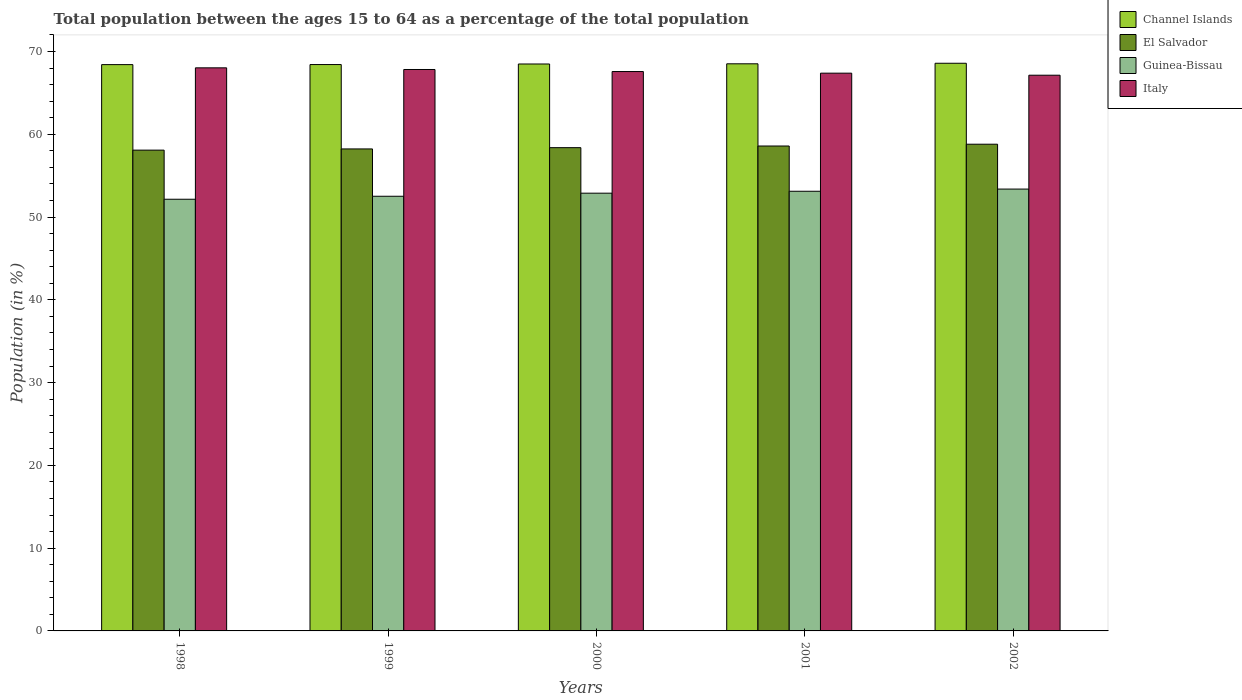How many groups of bars are there?
Give a very brief answer. 5. How many bars are there on the 1st tick from the left?
Your response must be concise. 4. How many bars are there on the 1st tick from the right?
Ensure brevity in your answer.  4. What is the label of the 4th group of bars from the left?
Ensure brevity in your answer.  2001. In how many cases, is the number of bars for a given year not equal to the number of legend labels?
Make the answer very short. 0. What is the percentage of the population ages 15 to 64 in Channel Islands in 1999?
Ensure brevity in your answer.  68.43. Across all years, what is the maximum percentage of the population ages 15 to 64 in Italy?
Provide a short and direct response. 68.03. Across all years, what is the minimum percentage of the population ages 15 to 64 in Italy?
Your answer should be very brief. 67.14. In which year was the percentage of the population ages 15 to 64 in Guinea-Bissau maximum?
Offer a terse response. 2002. What is the total percentage of the population ages 15 to 64 in Guinea-Bissau in the graph?
Provide a short and direct response. 264.06. What is the difference between the percentage of the population ages 15 to 64 in Italy in 1998 and that in 2000?
Keep it short and to the point. 0.45. What is the difference between the percentage of the population ages 15 to 64 in El Salvador in 2000 and the percentage of the population ages 15 to 64 in Guinea-Bissau in 1999?
Your response must be concise. 5.87. What is the average percentage of the population ages 15 to 64 in El Salvador per year?
Your answer should be compact. 58.42. In the year 2000, what is the difference between the percentage of the population ages 15 to 64 in Channel Islands and percentage of the population ages 15 to 64 in Guinea-Bissau?
Your answer should be very brief. 15.61. What is the ratio of the percentage of the population ages 15 to 64 in Italy in 2000 to that in 2002?
Your response must be concise. 1.01. Is the percentage of the population ages 15 to 64 in El Salvador in 2001 less than that in 2002?
Ensure brevity in your answer.  Yes. Is the difference between the percentage of the population ages 15 to 64 in Channel Islands in 1999 and 2002 greater than the difference between the percentage of the population ages 15 to 64 in Guinea-Bissau in 1999 and 2002?
Offer a terse response. Yes. What is the difference between the highest and the second highest percentage of the population ages 15 to 64 in Guinea-Bissau?
Your response must be concise. 0.26. What is the difference between the highest and the lowest percentage of the population ages 15 to 64 in El Salvador?
Keep it short and to the point. 0.72. In how many years, is the percentage of the population ages 15 to 64 in Guinea-Bissau greater than the average percentage of the population ages 15 to 64 in Guinea-Bissau taken over all years?
Offer a very short reply. 3. What does the 4th bar from the left in 2001 represents?
Provide a short and direct response. Italy. What does the 2nd bar from the right in 2001 represents?
Your answer should be very brief. Guinea-Bissau. Is it the case that in every year, the sum of the percentage of the population ages 15 to 64 in Italy and percentage of the population ages 15 to 64 in Guinea-Bissau is greater than the percentage of the population ages 15 to 64 in El Salvador?
Offer a terse response. Yes. How many bars are there?
Provide a short and direct response. 20. Are all the bars in the graph horizontal?
Your answer should be very brief. No. How many years are there in the graph?
Offer a very short reply. 5. What is the difference between two consecutive major ticks on the Y-axis?
Ensure brevity in your answer.  10. Does the graph contain any zero values?
Make the answer very short. No. Does the graph contain grids?
Provide a short and direct response. No. Where does the legend appear in the graph?
Provide a succinct answer. Top right. How are the legend labels stacked?
Ensure brevity in your answer.  Vertical. What is the title of the graph?
Make the answer very short. Total population between the ages 15 to 64 as a percentage of the total population. What is the label or title of the Y-axis?
Ensure brevity in your answer.  Population (in %). What is the Population (in %) in Channel Islands in 1998?
Offer a terse response. 68.42. What is the Population (in %) of El Salvador in 1998?
Provide a short and direct response. 58.09. What is the Population (in %) in Guinea-Bissau in 1998?
Your response must be concise. 52.16. What is the Population (in %) of Italy in 1998?
Make the answer very short. 68.03. What is the Population (in %) in Channel Islands in 1999?
Provide a short and direct response. 68.43. What is the Population (in %) in El Salvador in 1999?
Keep it short and to the point. 58.23. What is the Population (in %) in Guinea-Bissau in 1999?
Offer a very short reply. 52.52. What is the Population (in %) of Italy in 1999?
Your answer should be compact. 67.83. What is the Population (in %) in Channel Islands in 2000?
Provide a short and direct response. 68.5. What is the Population (in %) of El Salvador in 2000?
Offer a very short reply. 58.39. What is the Population (in %) in Guinea-Bissau in 2000?
Ensure brevity in your answer.  52.89. What is the Population (in %) in Italy in 2000?
Make the answer very short. 67.58. What is the Population (in %) of Channel Islands in 2001?
Make the answer very short. 68.52. What is the Population (in %) of El Salvador in 2001?
Ensure brevity in your answer.  58.59. What is the Population (in %) in Guinea-Bissau in 2001?
Your answer should be compact. 53.12. What is the Population (in %) in Italy in 2001?
Your response must be concise. 67.39. What is the Population (in %) of Channel Islands in 2002?
Give a very brief answer. 68.58. What is the Population (in %) of El Salvador in 2002?
Your answer should be compact. 58.8. What is the Population (in %) of Guinea-Bissau in 2002?
Ensure brevity in your answer.  53.38. What is the Population (in %) in Italy in 2002?
Your response must be concise. 67.14. Across all years, what is the maximum Population (in %) of Channel Islands?
Provide a short and direct response. 68.58. Across all years, what is the maximum Population (in %) in El Salvador?
Offer a terse response. 58.8. Across all years, what is the maximum Population (in %) of Guinea-Bissau?
Make the answer very short. 53.38. Across all years, what is the maximum Population (in %) in Italy?
Keep it short and to the point. 68.03. Across all years, what is the minimum Population (in %) in Channel Islands?
Your answer should be compact. 68.42. Across all years, what is the minimum Population (in %) of El Salvador?
Provide a short and direct response. 58.09. Across all years, what is the minimum Population (in %) in Guinea-Bissau?
Make the answer very short. 52.16. Across all years, what is the minimum Population (in %) in Italy?
Provide a succinct answer. 67.14. What is the total Population (in %) in Channel Islands in the graph?
Give a very brief answer. 342.45. What is the total Population (in %) of El Salvador in the graph?
Your response must be concise. 292.1. What is the total Population (in %) in Guinea-Bissau in the graph?
Make the answer very short. 264.06. What is the total Population (in %) of Italy in the graph?
Provide a short and direct response. 337.98. What is the difference between the Population (in %) in Channel Islands in 1998 and that in 1999?
Give a very brief answer. -0.01. What is the difference between the Population (in %) in El Salvador in 1998 and that in 1999?
Your answer should be compact. -0.15. What is the difference between the Population (in %) in Guinea-Bissau in 1998 and that in 1999?
Offer a terse response. -0.36. What is the difference between the Population (in %) of Italy in 1998 and that in 1999?
Ensure brevity in your answer.  0.2. What is the difference between the Population (in %) in Channel Islands in 1998 and that in 2000?
Make the answer very short. -0.08. What is the difference between the Population (in %) in El Salvador in 1998 and that in 2000?
Offer a terse response. -0.3. What is the difference between the Population (in %) in Guinea-Bissau in 1998 and that in 2000?
Your answer should be compact. -0.73. What is the difference between the Population (in %) in Italy in 1998 and that in 2000?
Your answer should be very brief. 0.45. What is the difference between the Population (in %) in Channel Islands in 1998 and that in 2001?
Your answer should be compact. -0.1. What is the difference between the Population (in %) in El Salvador in 1998 and that in 2001?
Offer a very short reply. -0.5. What is the difference between the Population (in %) of Guinea-Bissau in 1998 and that in 2001?
Your answer should be very brief. -0.96. What is the difference between the Population (in %) of Italy in 1998 and that in 2001?
Your response must be concise. 0.64. What is the difference between the Population (in %) in Channel Islands in 1998 and that in 2002?
Your answer should be very brief. -0.16. What is the difference between the Population (in %) in El Salvador in 1998 and that in 2002?
Provide a short and direct response. -0.72. What is the difference between the Population (in %) of Guinea-Bissau in 1998 and that in 2002?
Make the answer very short. -1.23. What is the difference between the Population (in %) of Italy in 1998 and that in 2002?
Provide a short and direct response. 0.89. What is the difference between the Population (in %) of Channel Islands in 1999 and that in 2000?
Provide a succinct answer. -0.07. What is the difference between the Population (in %) in El Salvador in 1999 and that in 2000?
Your answer should be compact. -0.15. What is the difference between the Population (in %) of Guinea-Bissau in 1999 and that in 2000?
Offer a very short reply. -0.37. What is the difference between the Population (in %) of Italy in 1999 and that in 2000?
Your answer should be compact. 0.25. What is the difference between the Population (in %) of Channel Islands in 1999 and that in 2001?
Your answer should be very brief. -0.09. What is the difference between the Population (in %) of El Salvador in 1999 and that in 2001?
Make the answer very short. -0.35. What is the difference between the Population (in %) in Guinea-Bissau in 1999 and that in 2001?
Offer a terse response. -0.6. What is the difference between the Population (in %) of Italy in 1999 and that in 2001?
Your response must be concise. 0.44. What is the difference between the Population (in %) of Channel Islands in 1999 and that in 2002?
Provide a succinct answer. -0.16. What is the difference between the Population (in %) in El Salvador in 1999 and that in 2002?
Ensure brevity in your answer.  -0.57. What is the difference between the Population (in %) in Guinea-Bissau in 1999 and that in 2002?
Provide a short and direct response. -0.87. What is the difference between the Population (in %) in Italy in 1999 and that in 2002?
Ensure brevity in your answer.  0.69. What is the difference between the Population (in %) of Channel Islands in 2000 and that in 2001?
Offer a very short reply. -0.02. What is the difference between the Population (in %) of El Salvador in 2000 and that in 2001?
Offer a terse response. -0.2. What is the difference between the Population (in %) of Guinea-Bissau in 2000 and that in 2001?
Your response must be concise. -0.23. What is the difference between the Population (in %) of Italy in 2000 and that in 2001?
Give a very brief answer. 0.2. What is the difference between the Population (in %) of Channel Islands in 2000 and that in 2002?
Your answer should be very brief. -0.09. What is the difference between the Population (in %) in El Salvador in 2000 and that in 2002?
Offer a very short reply. -0.42. What is the difference between the Population (in %) in Guinea-Bissau in 2000 and that in 2002?
Make the answer very short. -0.5. What is the difference between the Population (in %) in Italy in 2000 and that in 2002?
Provide a short and direct response. 0.44. What is the difference between the Population (in %) in Channel Islands in 2001 and that in 2002?
Keep it short and to the point. -0.07. What is the difference between the Population (in %) in El Salvador in 2001 and that in 2002?
Give a very brief answer. -0.22. What is the difference between the Population (in %) of Guinea-Bissau in 2001 and that in 2002?
Provide a succinct answer. -0.26. What is the difference between the Population (in %) of Italy in 2001 and that in 2002?
Your answer should be compact. 0.25. What is the difference between the Population (in %) of Channel Islands in 1998 and the Population (in %) of El Salvador in 1999?
Ensure brevity in your answer.  10.19. What is the difference between the Population (in %) in Channel Islands in 1998 and the Population (in %) in Guinea-Bissau in 1999?
Provide a succinct answer. 15.9. What is the difference between the Population (in %) of Channel Islands in 1998 and the Population (in %) of Italy in 1999?
Provide a short and direct response. 0.59. What is the difference between the Population (in %) in El Salvador in 1998 and the Population (in %) in Guinea-Bissau in 1999?
Your response must be concise. 5.57. What is the difference between the Population (in %) of El Salvador in 1998 and the Population (in %) of Italy in 1999?
Make the answer very short. -9.74. What is the difference between the Population (in %) of Guinea-Bissau in 1998 and the Population (in %) of Italy in 1999?
Make the answer very short. -15.67. What is the difference between the Population (in %) of Channel Islands in 1998 and the Population (in %) of El Salvador in 2000?
Provide a succinct answer. 10.03. What is the difference between the Population (in %) of Channel Islands in 1998 and the Population (in %) of Guinea-Bissau in 2000?
Keep it short and to the point. 15.53. What is the difference between the Population (in %) of Channel Islands in 1998 and the Population (in %) of Italy in 2000?
Keep it short and to the point. 0.84. What is the difference between the Population (in %) of El Salvador in 1998 and the Population (in %) of Guinea-Bissau in 2000?
Give a very brief answer. 5.2. What is the difference between the Population (in %) of El Salvador in 1998 and the Population (in %) of Italy in 2000?
Provide a short and direct response. -9.5. What is the difference between the Population (in %) in Guinea-Bissau in 1998 and the Population (in %) in Italy in 2000?
Provide a short and direct response. -15.43. What is the difference between the Population (in %) in Channel Islands in 1998 and the Population (in %) in El Salvador in 2001?
Ensure brevity in your answer.  9.83. What is the difference between the Population (in %) of Channel Islands in 1998 and the Population (in %) of Guinea-Bissau in 2001?
Your answer should be compact. 15.3. What is the difference between the Population (in %) in Channel Islands in 1998 and the Population (in %) in Italy in 2001?
Your answer should be compact. 1.03. What is the difference between the Population (in %) of El Salvador in 1998 and the Population (in %) of Guinea-Bissau in 2001?
Keep it short and to the point. 4.97. What is the difference between the Population (in %) of El Salvador in 1998 and the Population (in %) of Italy in 2001?
Provide a short and direct response. -9.3. What is the difference between the Population (in %) in Guinea-Bissau in 1998 and the Population (in %) in Italy in 2001?
Ensure brevity in your answer.  -15.23. What is the difference between the Population (in %) of Channel Islands in 1998 and the Population (in %) of El Salvador in 2002?
Keep it short and to the point. 9.62. What is the difference between the Population (in %) of Channel Islands in 1998 and the Population (in %) of Guinea-Bissau in 2002?
Provide a succinct answer. 15.04. What is the difference between the Population (in %) of Channel Islands in 1998 and the Population (in %) of Italy in 2002?
Offer a very short reply. 1.28. What is the difference between the Population (in %) of El Salvador in 1998 and the Population (in %) of Guinea-Bissau in 2002?
Keep it short and to the point. 4.71. What is the difference between the Population (in %) in El Salvador in 1998 and the Population (in %) in Italy in 2002?
Your answer should be compact. -9.05. What is the difference between the Population (in %) of Guinea-Bissau in 1998 and the Population (in %) of Italy in 2002?
Ensure brevity in your answer.  -14.99. What is the difference between the Population (in %) of Channel Islands in 1999 and the Population (in %) of El Salvador in 2000?
Offer a very short reply. 10.04. What is the difference between the Population (in %) in Channel Islands in 1999 and the Population (in %) in Guinea-Bissau in 2000?
Ensure brevity in your answer.  15.54. What is the difference between the Population (in %) in Channel Islands in 1999 and the Population (in %) in Italy in 2000?
Make the answer very short. 0.84. What is the difference between the Population (in %) in El Salvador in 1999 and the Population (in %) in Guinea-Bissau in 2000?
Provide a succinct answer. 5.35. What is the difference between the Population (in %) of El Salvador in 1999 and the Population (in %) of Italy in 2000?
Provide a succinct answer. -9.35. What is the difference between the Population (in %) in Guinea-Bissau in 1999 and the Population (in %) in Italy in 2000?
Make the answer very short. -15.07. What is the difference between the Population (in %) of Channel Islands in 1999 and the Population (in %) of El Salvador in 2001?
Your answer should be very brief. 9.84. What is the difference between the Population (in %) in Channel Islands in 1999 and the Population (in %) in Guinea-Bissau in 2001?
Make the answer very short. 15.31. What is the difference between the Population (in %) in Channel Islands in 1999 and the Population (in %) in Italy in 2001?
Give a very brief answer. 1.04. What is the difference between the Population (in %) in El Salvador in 1999 and the Population (in %) in Guinea-Bissau in 2001?
Your response must be concise. 5.11. What is the difference between the Population (in %) in El Salvador in 1999 and the Population (in %) in Italy in 2001?
Your answer should be very brief. -9.15. What is the difference between the Population (in %) in Guinea-Bissau in 1999 and the Population (in %) in Italy in 2001?
Your response must be concise. -14.87. What is the difference between the Population (in %) in Channel Islands in 1999 and the Population (in %) in El Salvador in 2002?
Keep it short and to the point. 9.62. What is the difference between the Population (in %) of Channel Islands in 1999 and the Population (in %) of Guinea-Bissau in 2002?
Offer a terse response. 15.04. What is the difference between the Population (in %) in Channel Islands in 1999 and the Population (in %) in Italy in 2002?
Offer a terse response. 1.29. What is the difference between the Population (in %) of El Salvador in 1999 and the Population (in %) of Guinea-Bissau in 2002?
Give a very brief answer. 4.85. What is the difference between the Population (in %) of El Salvador in 1999 and the Population (in %) of Italy in 2002?
Offer a terse response. -8.91. What is the difference between the Population (in %) of Guinea-Bissau in 1999 and the Population (in %) of Italy in 2002?
Your response must be concise. -14.63. What is the difference between the Population (in %) of Channel Islands in 2000 and the Population (in %) of El Salvador in 2001?
Give a very brief answer. 9.91. What is the difference between the Population (in %) in Channel Islands in 2000 and the Population (in %) in Guinea-Bissau in 2001?
Provide a succinct answer. 15.38. What is the difference between the Population (in %) in Channel Islands in 2000 and the Population (in %) in Italy in 2001?
Make the answer very short. 1.11. What is the difference between the Population (in %) of El Salvador in 2000 and the Population (in %) of Guinea-Bissau in 2001?
Your response must be concise. 5.27. What is the difference between the Population (in %) in El Salvador in 2000 and the Population (in %) in Italy in 2001?
Offer a terse response. -9. What is the difference between the Population (in %) in Channel Islands in 2000 and the Population (in %) in El Salvador in 2002?
Provide a short and direct response. 9.69. What is the difference between the Population (in %) of Channel Islands in 2000 and the Population (in %) of Guinea-Bissau in 2002?
Your response must be concise. 15.11. What is the difference between the Population (in %) of Channel Islands in 2000 and the Population (in %) of Italy in 2002?
Your response must be concise. 1.36. What is the difference between the Population (in %) in El Salvador in 2000 and the Population (in %) in Guinea-Bissau in 2002?
Provide a short and direct response. 5. What is the difference between the Population (in %) of El Salvador in 2000 and the Population (in %) of Italy in 2002?
Offer a very short reply. -8.75. What is the difference between the Population (in %) of Guinea-Bissau in 2000 and the Population (in %) of Italy in 2002?
Keep it short and to the point. -14.25. What is the difference between the Population (in %) in Channel Islands in 2001 and the Population (in %) in El Salvador in 2002?
Ensure brevity in your answer.  9.71. What is the difference between the Population (in %) of Channel Islands in 2001 and the Population (in %) of Guinea-Bissau in 2002?
Offer a very short reply. 15.14. What is the difference between the Population (in %) in Channel Islands in 2001 and the Population (in %) in Italy in 2002?
Keep it short and to the point. 1.38. What is the difference between the Population (in %) of El Salvador in 2001 and the Population (in %) of Guinea-Bissau in 2002?
Ensure brevity in your answer.  5.2. What is the difference between the Population (in %) in El Salvador in 2001 and the Population (in %) in Italy in 2002?
Make the answer very short. -8.55. What is the difference between the Population (in %) in Guinea-Bissau in 2001 and the Population (in %) in Italy in 2002?
Make the answer very short. -14.02. What is the average Population (in %) of Channel Islands per year?
Keep it short and to the point. 68.49. What is the average Population (in %) of El Salvador per year?
Offer a very short reply. 58.42. What is the average Population (in %) in Guinea-Bissau per year?
Make the answer very short. 52.81. What is the average Population (in %) in Italy per year?
Ensure brevity in your answer.  67.6. In the year 1998, what is the difference between the Population (in %) in Channel Islands and Population (in %) in El Salvador?
Keep it short and to the point. 10.33. In the year 1998, what is the difference between the Population (in %) of Channel Islands and Population (in %) of Guinea-Bissau?
Keep it short and to the point. 16.26. In the year 1998, what is the difference between the Population (in %) in Channel Islands and Population (in %) in Italy?
Keep it short and to the point. 0.39. In the year 1998, what is the difference between the Population (in %) in El Salvador and Population (in %) in Guinea-Bissau?
Your response must be concise. 5.93. In the year 1998, what is the difference between the Population (in %) of El Salvador and Population (in %) of Italy?
Your response must be concise. -9.94. In the year 1998, what is the difference between the Population (in %) in Guinea-Bissau and Population (in %) in Italy?
Your answer should be very brief. -15.88. In the year 1999, what is the difference between the Population (in %) of Channel Islands and Population (in %) of El Salvador?
Your answer should be very brief. 10.19. In the year 1999, what is the difference between the Population (in %) in Channel Islands and Population (in %) in Guinea-Bissau?
Give a very brief answer. 15.91. In the year 1999, what is the difference between the Population (in %) of Channel Islands and Population (in %) of Italy?
Offer a very short reply. 0.6. In the year 1999, what is the difference between the Population (in %) in El Salvador and Population (in %) in Guinea-Bissau?
Give a very brief answer. 5.72. In the year 1999, what is the difference between the Population (in %) in El Salvador and Population (in %) in Italy?
Keep it short and to the point. -9.6. In the year 1999, what is the difference between the Population (in %) of Guinea-Bissau and Population (in %) of Italy?
Make the answer very short. -15.31. In the year 2000, what is the difference between the Population (in %) in Channel Islands and Population (in %) in El Salvador?
Keep it short and to the point. 10.11. In the year 2000, what is the difference between the Population (in %) of Channel Islands and Population (in %) of Guinea-Bissau?
Make the answer very short. 15.61. In the year 2000, what is the difference between the Population (in %) of Channel Islands and Population (in %) of Italy?
Your answer should be compact. 0.91. In the year 2000, what is the difference between the Population (in %) of El Salvador and Population (in %) of Guinea-Bissau?
Provide a short and direct response. 5.5. In the year 2000, what is the difference between the Population (in %) in El Salvador and Population (in %) in Italy?
Provide a short and direct response. -9.2. In the year 2000, what is the difference between the Population (in %) of Guinea-Bissau and Population (in %) of Italy?
Make the answer very short. -14.7. In the year 2001, what is the difference between the Population (in %) in Channel Islands and Population (in %) in El Salvador?
Make the answer very short. 9.93. In the year 2001, what is the difference between the Population (in %) of Channel Islands and Population (in %) of Guinea-Bissau?
Provide a succinct answer. 15.4. In the year 2001, what is the difference between the Population (in %) of Channel Islands and Population (in %) of Italy?
Your response must be concise. 1.13. In the year 2001, what is the difference between the Population (in %) in El Salvador and Population (in %) in Guinea-Bissau?
Ensure brevity in your answer.  5.47. In the year 2001, what is the difference between the Population (in %) of El Salvador and Population (in %) of Italy?
Make the answer very short. -8.8. In the year 2001, what is the difference between the Population (in %) in Guinea-Bissau and Population (in %) in Italy?
Provide a succinct answer. -14.27. In the year 2002, what is the difference between the Population (in %) of Channel Islands and Population (in %) of El Salvador?
Ensure brevity in your answer.  9.78. In the year 2002, what is the difference between the Population (in %) in Channel Islands and Population (in %) in Guinea-Bissau?
Ensure brevity in your answer.  15.2. In the year 2002, what is the difference between the Population (in %) of Channel Islands and Population (in %) of Italy?
Provide a short and direct response. 1.44. In the year 2002, what is the difference between the Population (in %) in El Salvador and Population (in %) in Guinea-Bissau?
Offer a very short reply. 5.42. In the year 2002, what is the difference between the Population (in %) in El Salvador and Population (in %) in Italy?
Keep it short and to the point. -8.34. In the year 2002, what is the difference between the Population (in %) in Guinea-Bissau and Population (in %) in Italy?
Give a very brief answer. -13.76. What is the ratio of the Population (in %) in El Salvador in 1998 to that in 1999?
Your answer should be compact. 1. What is the ratio of the Population (in %) in El Salvador in 1998 to that in 2000?
Make the answer very short. 0.99. What is the ratio of the Population (in %) of Guinea-Bissau in 1998 to that in 2000?
Provide a succinct answer. 0.99. What is the ratio of the Population (in %) of Italy in 1998 to that in 2000?
Your response must be concise. 1.01. What is the ratio of the Population (in %) in Guinea-Bissau in 1998 to that in 2001?
Provide a short and direct response. 0.98. What is the ratio of the Population (in %) of Italy in 1998 to that in 2001?
Your response must be concise. 1.01. What is the ratio of the Population (in %) of Channel Islands in 1998 to that in 2002?
Your response must be concise. 1. What is the ratio of the Population (in %) of El Salvador in 1998 to that in 2002?
Keep it short and to the point. 0.99. What is the ratio of the Population (in %) in Guinea-Bissau in 1998 to that in 2002?
Your answer should be compact. 0.98. What is the ratio of the Population (in %) of Italy in 1998 to that in 2002?
Your answer should be compact. 1.01. What is the ratio of the Population (in %) in El Salvador in 1999 to that in 2000?
Give a very brief answer. 1. What is the ratio of the Population (in %) of El Salvador in 1999 to that in 2001?
Offer a terse response. 0.99. What is the ratio of the Population (in %) of Guinea-Bissau in 1999 to that in 2001?
Give a very brief answer. 0.99. What is the ratio of the Population (in %) in Italy in 1999 to that in 2001?
Make the answer very short. 1.01. What is the ratio of the Population (in %) of Channel Islands in 1999 to that in 2002?
Your response must be concise. 1. What is the ratio of the Population (in %) in El Salvador in 1999 to that in 2002?
Your answer should be very brief. 0.99. What is the ratio of the Population (in %) in Guinea-Bissau in 1999 to that in 2002?
Your answer should be compact. 0.98. What is the ratio of the Population (in %) of Italy in 1999 to that in 2002?
Your answer should be compact. 1.01. What is the ratio of the Population (in %) in Channel Islands in 2000 to that in 2001?
Offer a terse response. 1. What is the ratio of the Population (in %) in El Salvador in 2000 to that in 2001?
Keep it short and to the point. 1. What is the ratio of the Population (in %) of Guinea-Bissau in 2000 to that in 2001?
Your answer should be compact. 1. What is the ratio of the Population (in %) of Italy in 2000 to that in 2001?
Keep it short and to the point. 1. What is the ratio of the Population (in %) in Channel Islands in 2000 to that in 2002?
Your answer should be compact. 1. What is the ratio of the Population (in %) in Italy in 2000 to that in 2002?
Make the answer very short. 1.01. What is the ratio of the Population (in %) of Channel Islands in 2001 to that in 2002?
Your answer should be compact. 1. What is the ratio of the Population (in %) of El Salvador in 2001 to that in 2002?
Your answer should be very brief. 1. What is the difference between the highest and the second highest Population (in %) of Channel Islands?
Your response must be concise. 0.07. What is the difference between the highest and the second highest Population (in %) in El Salvador?
Offer a terse response. 0.22. What is the difference between the highest and the second highest Population (in %) of Guinea-Bissau?
Provide a short and direct response. 0.26. What is the difference between the highest and the second highest Population (in %) in Italy?
Provide a succinct answer. 0.2. What is the difference between the highest and the lowest Population (in %) of Channel Islands?
Offer a very short reply. 0.16. What is the difference between the highest and the lowest Population (in %) of El Salvador?
Give a very brief answer. 0.72. What is the difference between the highest and the lowest Population (in %) of Guinea-Bissau?
Your answer should be compact. 1.23. What is the difference between the highest and the lowest Population (in %) in Italy?
Keep it short and to the point. 0.89. 